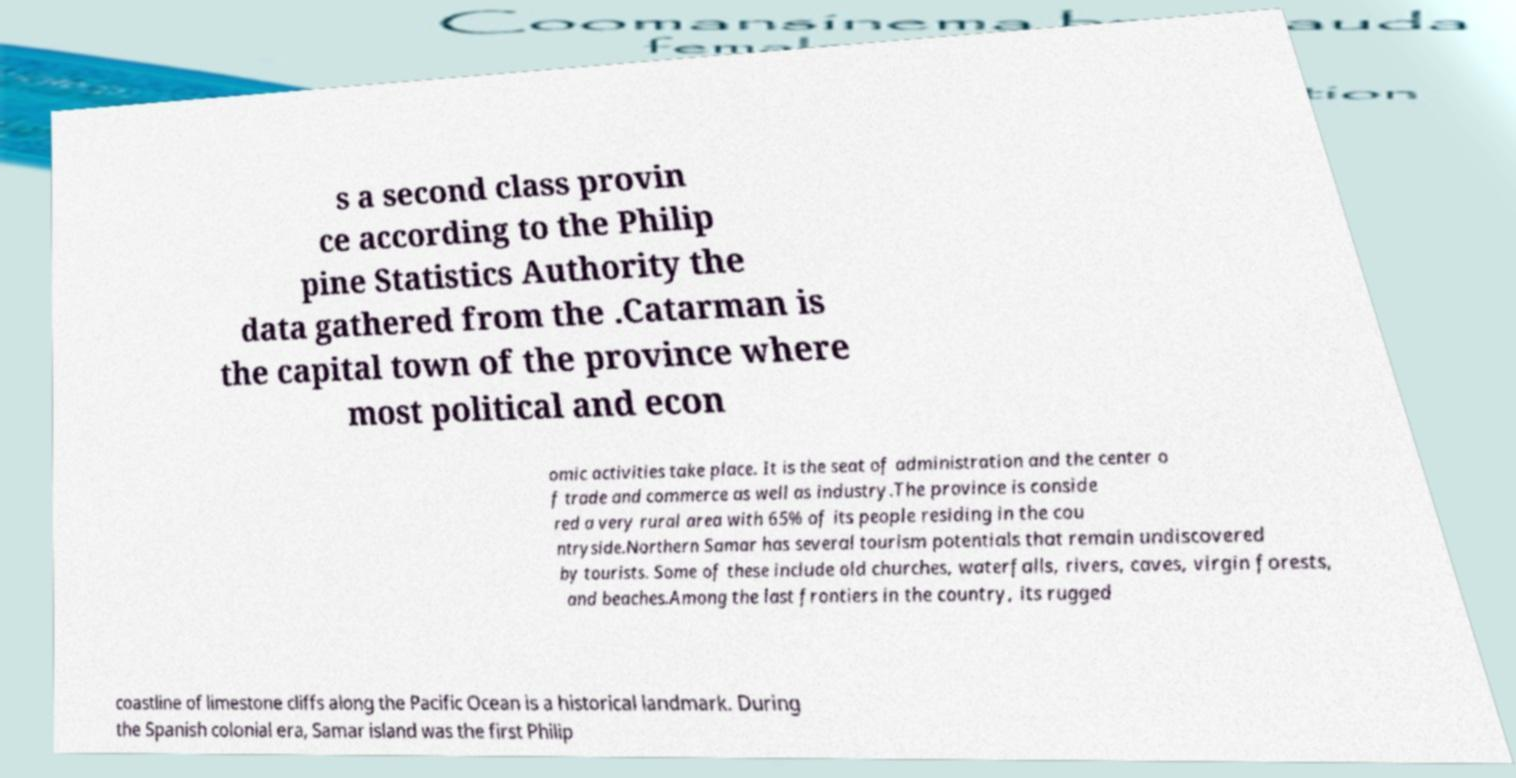I need the written content from this picture converted into text. Can you do that? s a second class provin ce according to the Philip pine Statistics Authority the data gathered from the .Catarman is the capital town of the province where most political and econ omic activities take place. It is the seat of administration and the center o f trade and commerce as well as industry.The province is conside red a very rural area with 65% of its people residing in the cou ntryside.Northern Samar has several tourism potentials that remain undiscovered by tourists. Some of these include old churches, waterfalls, rivers, caves, virgin forests, and beaches.Among the last frontiers in the country, its rugged coastline of limestone cliffs along the Pacific Ocean is a historical landmark. During the Spanish colonial era, Samar island was the first Philip 